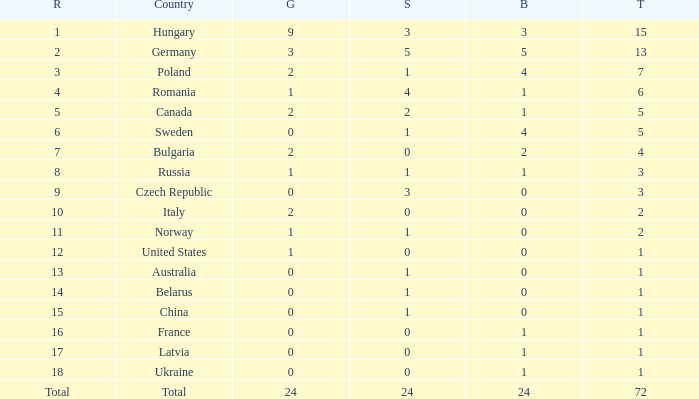What average total has 0 as the gold, with 6 as the rank? 5.0. Give me the full table as a dictionary. {'header': ['R', 'Country', 'G', 'S', 'B', 'T'], 'rows': [['1', 'Hungary', '9', '3', '3', '15'], ['2', 'Germany', '3', '5', '5', '13'], ['3', 'Poland', '2', '1', '4', '7'], ['4', 'Romania', '1', '4', '1', '6'], ['5', 'Canada', '2', '2', '1', '5'], ['6', 'Sweden', '0', '1', '4', '5'], ['7', 'Bulgaria', '2', '0', '2', '4'], ['8', 'Russia', '1', '1', '1', '3'], ['9', 'Czech Republic', '0', '3', '0', '3'], ['10', 'Italy', '2', '0', '0', '2'], ['11', 'Norway', '1', '1', '0', '2'], ['12', 'United States', '1', '0', '0', '1'], ['13', 'Australia', '0', '1', '0', '1'], ['14', 'Belarus', '0', '1', '0', '1'], ['15', 'China', '0', '1', '0', '1'], ['16', 'France', '0', '0', '1', '1'], ['17', 'Latvia', '0', '0', '1', '1'], ['18', 'Ukraine', '0', '0', '1', '1'], ['Total', 'Total', '24', '24', '24', '72']]} 